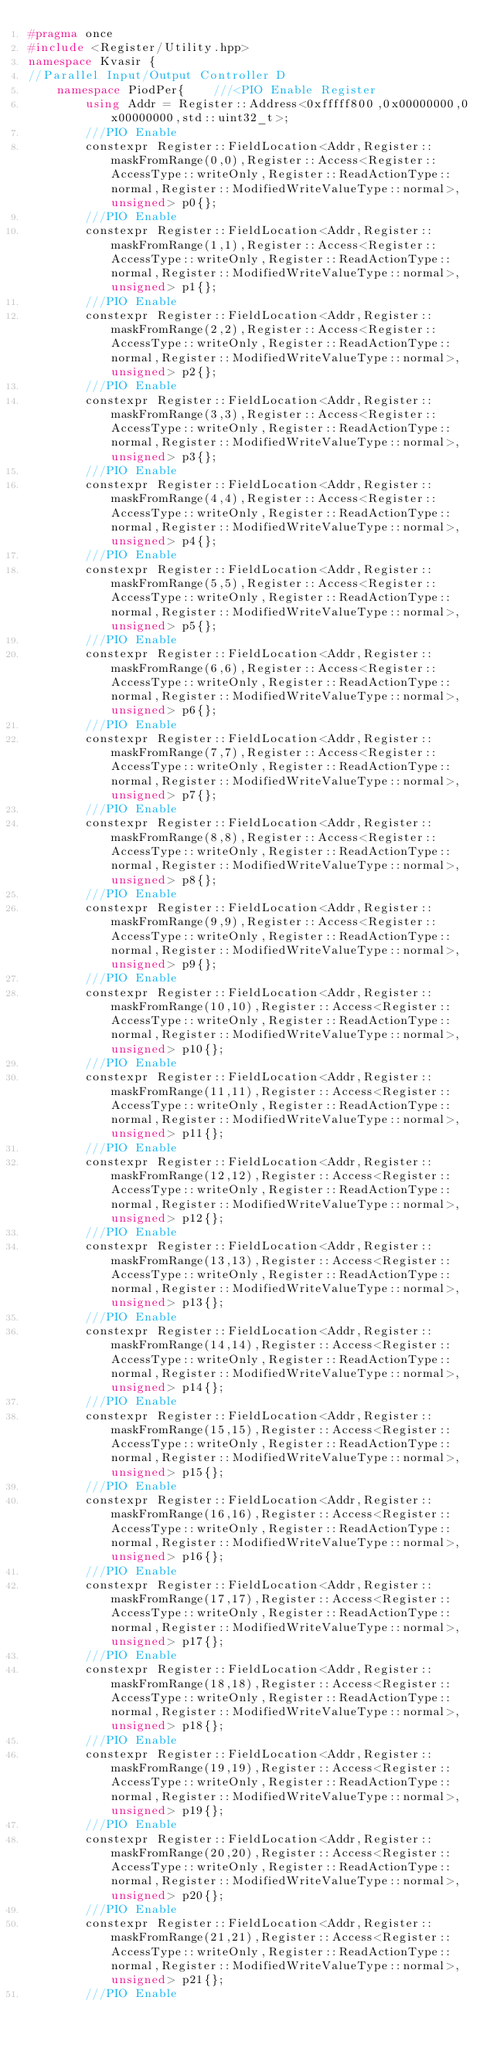Convert code to text. <code><loc_0><loc_0><loc_500><loc_500><_C++_>#pragma once 
#include <Register/Utility.hpp>
namespace Kvasir {
//Parallel Input/Output Controller D
    namespace PiodPer{    ///<PIO Enable Register
        using Addr = Register::Address<0xfffff800,0x00000000,0x00000000,std::uint32_t>;
        ///PIO Enable
        constexpr Register::FieldLocation<Addr,Register::maskFromRange(0,0),Register::Access<Register::AccessType::writeOnly,Register::ReadActionType::normal,Register::ModifiedWriteValueType::normal>,unsigned> p0{}; 
        ///PIO Enable
        constexpr Register::FieldLocation<Addr,Register::maskFromRange(1,1),Register::Access<Register::AccessType::writeOnly,Register::ReadActionType::normal,Register::ModifiedWriteValueType::normal>,unsigned> p1{}; 
        ///PIO Enable
        constexpr Register::FieldLocation<Addr,Register::maskFromRange(2,2),Register::Access<Register::AccessType::writeOnly,Register::ReadActionType::normal,Register::ModifiedWriteValueType::normal>,unsigned> p2{}; 
        ///PIO Enable
        constexpr Register::FieldLocation<Addr,Register::maskFromRange(3,3),Register::Access<Register::AccessType::writeOnly,Register::ReadActionType::normal,Register::ModifiedWriteValueType::normal>,unsigned> p3{}; 
        ///PIO Enable
        constexpr Register::FieldLocation<Addr,Register::maskFromRange(4,4),Register::Access<Register::AccessType::writeOnly,Register::ReadActionType::normal,Register::ModifiedWriteValueType::normal>,unsigned> p4{}; 
        ///PIO Enable
        constexpr Register::FieldLocation<Addr,Register::maskFromRange(5,5),Register::Access<Register::AccessType::writeOnly,Register::ReadActionType::normal,Register::ModifiedWriteValueType::normal>,unsigned> p5{}; 
        ///PIO Enable
        constexpr Register::FieldLocation<Addr,Register::maskFromRange(6,6),Register::Access<Register::AccessType::writeOnly,Register::ReadActionType::normal,Register::ModifiedWriteValueType::normal>,unsigned> p6{}; 
        ///PIO Enable
        constexpr Register::FieldLocation<Addr,Register::maskFromRange(7,7),Register::Access<Register::AccessType::writeOnly,Register::ReadActionType::normal,Register::ModifiedWriteValueType::normal>,unsigned> p7{}; 
        ///PIO Enable
        constexpr Register::FieldLocation<Addr,Register::maskFromRange(8,8),Register::Access<Register::AccessType::writeOnly,Register::ReadActionType::normal,Register::ModifiedWriteValueType::normal>,unsigned> p8{}; 
        ///PIO Enable
        constexpr Register::FieldLocation<Addr,Register::maskFromRange(9,9),Register::Access<Register::AccessType::writeOnly,Register::ReadActionType::normal,Register::ModifiedWriteValueType::normal>,unsigned> p9{}; 
        ///PIO Enable
        constexpr Register::FieldLocation<Addr,Register::maskFromRange(10,10),Register::Access<Register::AccessType::writeOnly,Register::ReadActionType::normal,Register::ModifiedWriteValueType::normal>,unsigned> p10{}; 
        ///PIO Enable
        constexpr Register::FieldLocation<Addr,Register::maskFromRange(11,11),Register::Access<Register::AccessType::writeOnly,Register::ReadActionType::normal,Register::ModifiedWriteValueType::normal>,unsigned> p11{}; 
        ///PIO Enable
        constexpr Register::FieldLocation<Addr,Register::maskFromRange(12,12),Register::Access<Register::AccessType::writeOnly,Register::ReadActionType::normal,Register::ModifiedWriteValueType::normal>,unsigned> p12{}; 
        ///PIO Enable
        constexpr Register::FieldLocation<Addr,Register::maskFromRange(13,13),Register::Access<Register::AccessType::writeOnly,Register::ReadActionType::normal,Register::ModifiedWriteValueType::normal>,unsigned> p13{}; 
        ///PIO Enable
        constexpr Register::FieldLocation<Addr,Register::maskFromRange(14,14),Register::Access<Register::AccessType::writeOnly,Register::ReadActionType::normal,Register::ModifiedWriteValueType::normal>,unsigned> p14{}; 
        ///PIO Enable
        constexpr Register::FieldLocation<Addr,Register::maskFromRange(15,15),Register::Access<Register::AccessType::writeOnly,Register::ReadActionType::normal,Register::ModifiedWriteValueType::normal>,unsigned> p15{}; 
        ///PIO Enable
        constexpr Register::FieldLocation<Addr,Register::maskFromRange(16,16),Register::Access<Register::AccessType::writeOnly,Register::ReadActionType::normal,Register::ModifiedWriteValueType::normal>,unsigned> p16{}; 
        ///PIO Enable
        constexpr Register::FieldLocation<Addr,Register::maskFromRange(17,17),Register::Access<Register::AccessType::writeOnly,Register::ReadActionType::normal,Register::ModifiedWriteValueType::normal>,unsigned> p17{}; 
        ///PIO Enable
        constexpr Register::FieldLocation<Addr,Register::maskFromRange(18,18),Register::Access<Register::AccessType::writeOnly,Register::ReadActionType::normal,Register::ModifiedWriteValueType::normal>,unsigned> p18{}; 
        ///PIO Enable
        constexpr Register::FieldLocation<Addr,Register::maskFromRange(19,19),Register::Access<Register::AccessType::writeOnly,Register::ReadActionType::normal,Register::ModifiedWriteValueType::normal>,unsigned> p19{}; 
        ///PIO Enable
        constexpr Register::FieldLocation<Addr,Register::maskFromRange(20,20),Register::Access<Register::AccessType::writeOnly,Register::ReadActionType::normal,Register::ModifiedWriteValueType::normal>,unsigned> p20{}; 
        ///PIO Enable
        constexpr Register::FieldLocation<Addr,Register::maskFromRange(21,21),Register::Access<Register::AccessType::writeOnly,Register::ReadActionType::normal,Register::ModifiedWriteValueType::normal>,unsigned> p21{}; 
        ///PIO Enable</code> 